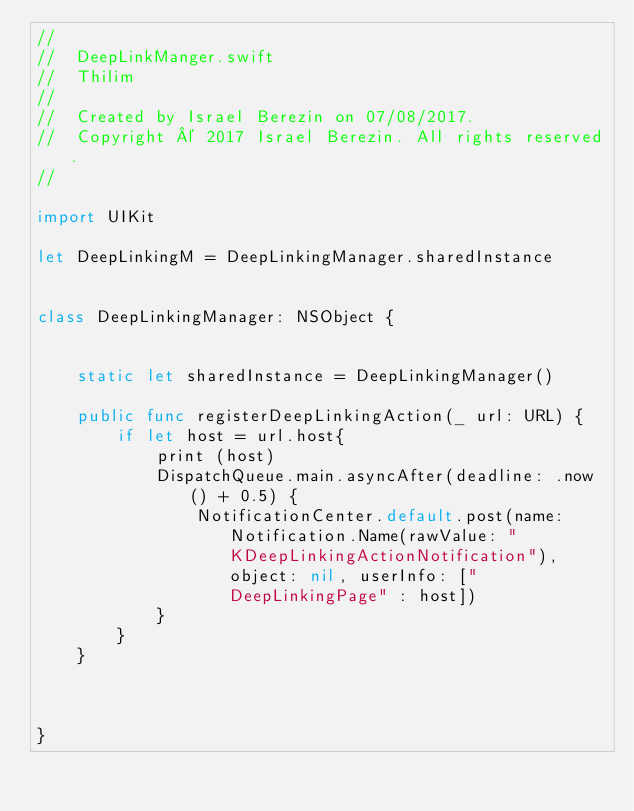<code> <loc_0><loc_0><loc_500><loc_500><_Swift_>//
//  DeepLinkManger.swift
//  Thilim
//
//  Created by Israel Berezin on 07/08/2017.
//  Copyright © 2017 Israel Berezin. All rights reserved.
//

import UIKit

let DeepLinkingM = DeepLinkingManager.sharedInstance


class DeepLinkingManager: NSObject {
    
    
    static let sharedInstance = DeepLinkingManager()
    
    public func registerDeepLinkingAction(_ url: URL) {
        if let host = url.host{
            print (host)
            DispatchQueue.main.asyncAfter(deadline: .now() + 0.5) {
                NotificationCenter.default.post(name: Notification.Name(rawValue: "KDeepLinkingActionNotification"), object: nil, userInfo: ["DeepLinkingPage" : host])
            }
        }
    }

    

}
</code> 